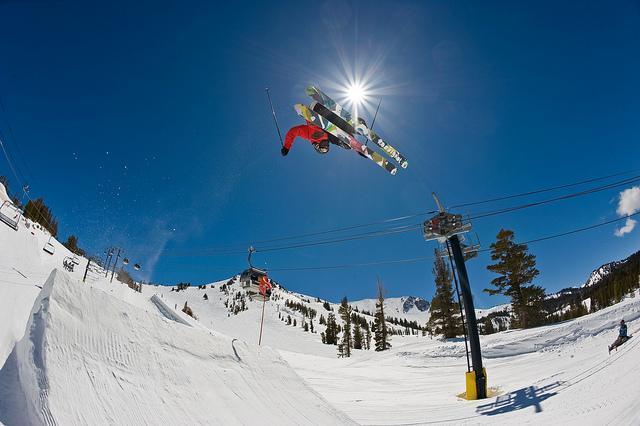How many trucks are racing?
Give a very brief answer. 0. 